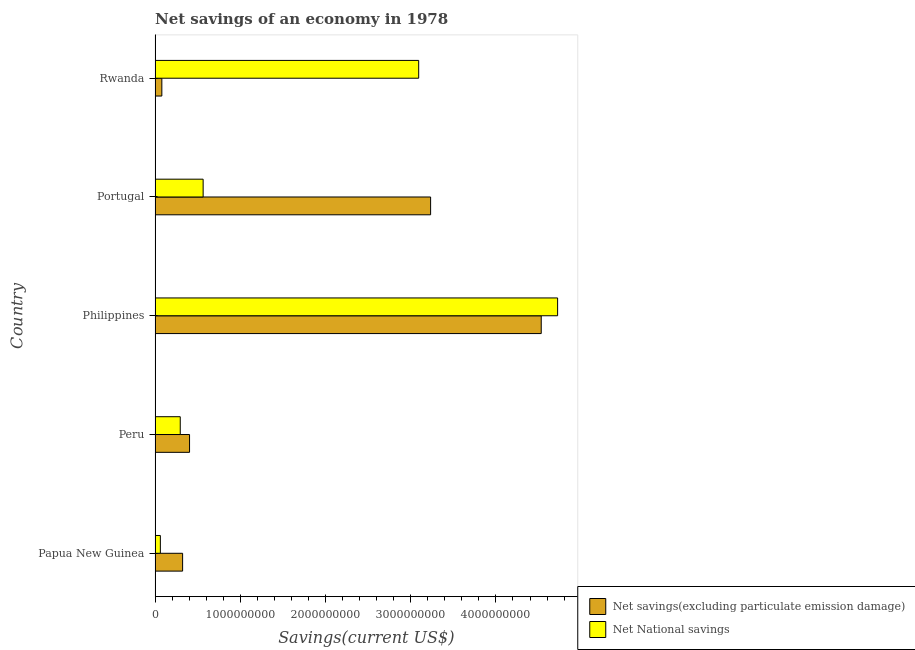How many bars are there on the 3rd tick from the bottom?
Ensure brevity in your answer.  2. In how many cases, is the number of bars for a given country not equal to the number of legend labels?
Keep it short and to the point. 0. What is the net national savings in Rwanda?
Your response must be concise. 3.09e+09. Across all countries, what is the maximum net national savings?
Provide a succinct answer. 4.72e+09. Across all countries, what is the minimum net savings(excluding particulate emission damage)?
Provide a succinct answer. 7.96e+07. In which country was the net national savings minimum?
Keep it short and to the point. Papua New Guinea. What is the total net national savings in the graph?
Provide a short and direct response. 8.74e+09. What is the difference between the net national savings in Papua New Guinea and that in Rwanda?
Keep it short and to the point. -3.03e+09. What is the difference between the net national savings in Papua New Guinea and the net savings(excluding particulate emission damage) in Peru?
Give a very brief answer. -3.43e+08. What is the average net savings(excluding particulate emission damage) per country?
Provide a succinct answer. 1.71e+09. What is the difference between the net savings(excluding particulate emission damage) and net national savings in Rwanda?
Ensure brevity in your answer.  -3.01e+09. In how many countries, is the net national savings greater than 2400000000 US$?
Your answer should be very brief. 2. What is the ratio of the net savings(excluding particulate emission damage) in Peru to that in Philippines?
Give a very brief answer. 0.09. Is the net national savings in Philippines less than that in Portugal?
Keep it short and to the point. No. Is the difference between the net national savings in Portugal and Rwanda greater than the difference between the net savings(excluding particulate emission damage) in Portugal and Rwanda?
Your answer should be very brief. No. What is the difference between the highest and the second highest net national savings?
Offer a terse response. 1.63e+09. What is the difference between the highest and the lowest net savings(excluding particulate emission damage)?
Provide a succinct answer. 4.45e+09. In how many countries, is the net national savings greater than the average net national savings taken over all countries?
Provide a succinct answer. 2. Is the sum of the net national savings in Peru and Rwanda greater than the maximum net savings(excluding particulate emission damage) across all countries?
Your answer should be very brief. No. What does the 1st bar from the top in Peru represents?
Provide a short and direct response. Net National savings. What does the 1st bar from the bottom in Papua New Guinea represents?
Give a very brief answer. Net savings(excluding particulate emission damage). How many bars are there?
Ensure brevity in your answer.  10. Are all the bars in the graph horizontal?
Your answer should be compact. Yes. Are the values on the major ticks of X-axis written in scientific E-notation?
Your answer should be compact. No. Does the graph contain any zero values?
Provide a short and direct response. No. Does the graph contain grids?
Provide a short and direct response. No. Where does the legend appear in the graph?
Your response must be concise. Bottom right. How are the legend labels stacked?
Give a very brief answer. Vertical. What is the title of the graph?
Ensure brevity in your answer.  Net savings of an economy in 1978. What is the label or title of the X-axis?
Your answer should be very brief. Savings(current US$). What is the label or title of the Y-axis?
Offer a very short reply. Country. What is the Savings(current US$) in Net savings(excluding particulate emission damage) in Papua New Guinea?
Offer a terse response. 3.23e+08. What is the Savings(current US$) of Net National savings in Papua New Guinea?
Keep it short and to the point. 6.22e+07. What is the Savings(current US$) in Net savings(excluding particulate emission damage) in Peru?
Offer a terse response. 4.05e+08. What is the Savings(current US$) in Net National savings in Peru?
Your answer should be compact. 2.96e+08. What is the Savings(current US$) in Net savings(excluding particulate emission damage) in Philippines?
Your answer should be compact. 4.53e+09. What is the Savings(current US$) in Net National savings in Philippines?
Your response must be concise. 4.72e+09. What is the Savings(current US$) of Net savings(excluding particulate emission damage) in Portugal?
Your response must be concise. 3.23e+09. What is the Savings(current US$) of Net National savings in Portugal?
Ensure brevity in your answer.  5.64e+08. What is the Savings(current US$) of Net savings(excluding particulate emission damage) in Rwanda?
Make the answer very short. 7.96e+07. What is the Savings(current US$) in Net National savings in Rwanda?
Make the answer very short. 3.09e+09. Across all countries, what is the maximum Savings(current US$) of Net savings(excluding particulate emission damage)?
Your answer should be very brief. 4.53e+09. Across all countries, what is the maximum Savings(current US$) of Net National savings?
Offer a very short reply. 4.72e+09. Across all countries, what is the minimum Savings(current US$) of Net savings(excluding particulate emission damage)?
Provide a short and direct response. 7.96e+07. Across all countries, what is the minimum Savings(current US$) in Net National savings?
Your response must be concise. 6.22e+07. What is the total Savings(current US$) of Net savings(excluding particulate emission damage) in the graph?
Your response must be concise. 8.57e+09. What is the total Savings(current US$) in Net National savings in the graph?
Provide a succinct answer. 8.74e+09. What is the difference between the Savings(current US$) in Net savings(excluding particulate emission damage) in Papua New Guinea and that in Peru?
Offer a terse response. -8.15e+07. What is the difference between the Savings(current US$) in Net National savings in Papua New Guinea and that in Peru?
Make the answer very short. -2.33e+08. What is the difference between the Savings(current US$) in Net savings(excluding particulate emission damage) in Papua New Guinea and that in Philippines?
Make the answer very short. -4.21e+09. What is the difference between the Savings(current US$) in Net National savings in Papua New Guinea and that in Philippines?
Your answer should be compact. -4.66e+09. What is the difference between the Savings(current US$) of Net savings(excluding particulate emission damage) in Papua New Guinea and that in Portugal?
Keep it short and to the point. -2.91e+09. What is the difference between the Savings(current US$) of Net National savings in Papua New Guinea and that in Portugal?
Give a very brief answer. -5.02e+08. What is the difference between the Savings(current US$) in Net savings(excluding particulate emission damage) in Papua New Guinea and that in Rwanda?
Your answer should be very brief. 2.44e+08. What is the difference between the Savings(current US$) of Net National savings in Papua New Guinea and that in Rwanda?
Ensure brevity in your answer.  -3.03e+09. What is the difference between the Savings(current US$) in Net savings(excluding particulate emission damage) in Peru and that in Philippines?
Provide a short and direct response. -4.13e+09. What is the difference between the Savings(current US$) in Net National savings in Peru and that in Philippines?
Offer a very short reply. -4.43e+09. What is the difference between the Savings(current US$) in Net savings(excluding particulate emission damage) in Peru and that in Portugal?
Provide a succinct answer. -2.83e+09. What is the difference between the Savings(current US$) of Net National savings in Peru and that in Portugal?
Provide a succinct answer. -2.69e+08. What is the difference between the Savings(current US$) in Net savings(excluding particulate emission damage) in Peru and that in Rwanda?
Your answer should be compact. 3.25e+08. What is the difference between the Savings(current US$) in Net National savings in Peru and that in Rwanda?
Ensure brevity in your answer.  -2.80e+09. What is the difference between the Savings(current US$) in Net savings(excluding particulate emission damage) in Philippines and that in Portugal?
Provide a short and direct response. 1.30e+09. What is the difference between the Savings(current US$) of Net National savings in Philippines and that in Portugal?
Make the answer very short. 4.16e+09. What is the difference between the Savings(current US$) in Net savings(excluding particulate emission damage) in Philippines and that in Rwanda?
Your answer should be very brief. 4.45e+09. What is the difference between the Savings(current US$) of Net National savings in Philippines and that in Rwanda?
Make the answer very short. 1.63e+09. What is the difference between the Savings(current US$) of Net savings(excluding particulate emission damage) in Portugal and that in Rwanda?
Provide a short and direct response. 3.15e+09. What is the difference between the Savings(current US$) of Net National savings in Portugal and that in Rwanda?
Give a very brief answer. -2.53e+09. What is the difference between the Savings(current US$) in Net savings(excluding particulate emission damage) in Papua New Guinea and the Savings(current US$) in Net National savings in Peru?
Give a very brief answer. 2.77e+07. What is the difference between the Savings(current US$) in Net savings(excluding particulate emission damage) in Papua New Guinea and the Savings(current US$) in Net National savings in Philippines?
Provide a short and direct response. -4.40e+09. What is the difference between the Savings(current US$) in Net savings(excluding particulate emission damage) in Papua New Guinea and the Savings(current US$) in Net National savings in Portugal?
Keep it short and to the point. -2.41e+08. What is the difference between the Savings(current US$) in Net savings(excluding particulate emission damage) in Papua New Guinea and the Savings(current US$) in Net National savings in Rwanda?
Offer a very short reply. -2.77e+09. What is the difference between the Savings(current US$) of Net savings(excluding particulate emission damage) in Peru and the Savings(current US$) of Net National savings in Philippines?
Provide a succinct answer. -4.32e+09. What is the difference between the Savings(current US$) of Net savings(excluding particulate emission damage) in Peru and the Savings(current US$) of Net National savings in Portugal?
Your answer should be very brief. -1.60e+08. What is the difference between the Savings(current US$) in Net savings(excluding particulate emission damage) in Peru and the Savings(current US$) in Net National savings in Rwanda?
Your answer should be compact. -2.69e+09. What is the difference between the Savings(current US$) of Net savings(excluding particulate emission damage) in Philippines and the Savings(current US$) of Net National savings in Portugal?
Provide a succinct answer. 3.97e+09. What is the difference between the Savings(current US$) of Net savings(excluding particulate emission damage) in Philippines and the Savings(current US$) of Net National savings in Rwanda?
Make the answer very short. 1.44e+09. What is the difference between the Savings(current US$) in Net savings(excluding particulate emission damage) in Portugal and the Savings(current US$) in Net National savings in Rwanda?
Make the answer very short. 1.40e+08. What is the average Savings(current US$) of Net savings(excluding particulate emission damage) per country?
Make the answer very short. 1.71e+09. What is the average Savings(current US$) in Net National savings per country?
Provide a short and direct response. 1.75e+09. What is the difference between the Savings(current US$) in Net savings(excluding particulate emission damage) and Savings(current US$) in Net National savings in Papua New Guinea?
Make the answer very short. 2.61e+08. What is the difference between the Savings(current US$) in Net savings(excluding particulate emission damage) and Savings(current US$) in Net National savings in Peru?
Ensure brevity in your answer.  1.09e+08. What is the difference between the Savings(current US$) of Net savings(excluding particulate emission damage) and Savings(current US$) of Net National savings in Philippines?
Ensure brevity in your answer.  -1.92e+08. What is the difference between the Savings(current US$) in Net savings(excluding particulate emission damage) and Savings(current US$) in Net National savings in Portugal?
Provide a short and direct response. 2.67e+09. What is the difference between the Savings(current US$) in Net savings(excluding particulate emission damage) and Savings(current US$) in Net National savings in Rwanda?
Keep it short and to the point. -3.01e+09. What is the ratio of the Savings(current US$) in Net savings(excluding particulate emission damage) in Papua New Guinea to that in Peru?
Offer a terse response. 0.8. What is the ratio of the Savings(current US$) in Net National savings in Papua New Guinea to that in Peru?
Your response must be concise. 0.21. What is the ratio of the Savings(current US$) of Net savings(excluding particulate emission damage) in Papua New Guinea to that in Philippines?
Your response must be concise. 0.07. What is the ratio of the Savings(current US$) of Net National savings in Papua New Guinea to that in Philippines?
Your answer should be very brief. 0.01. What is the ratio of the Savings(current US$) in Net savings(excluding particulate emission damage) in Papua New Guinea to that in Portugal?
Your answer should be very brief. 0.1. What is the ratio of the Savings(current US$) of Net National savings in Papua New Guinea to that in Portugal?
Give a very brief answer. 0.11. What is the ratio of the Savings(current US$) of Net savings(excluding particulate emission damage) in Papua New Guinea to that in Rwanda?
Provide a succinct answer. 4.06. What is the ratio of the Savings(current US$) in Net National savings in Papua New Guinea to that in Rwanda?
Offer a very short reply. 0.02. What is the ratio of the Savings(current US$) of Net savings(excluding particulate emission damage) in Peru to that in Philippines?
Provide a short and direct response. 0.09. What is the ratio of the Savings(current US$) in Net National savings in Peru to that in Philippines?
Your response must be concise. 0.06. What is the ratio of the Savings(current US$) of Net savings(excluding particulate emission damage) in Peru to that in Portugal?
Provide a short and direct response. 0.13. What is the ratio of the Savings(current US$) in Net National savings in Peru to that in Portugal?
Your answer should be very brief. 0.52. What is the ratio of the Savings(current US$) in Net savings(excluding particulate emission damage) in Peru to that in Rwanda?
Your answer should be very brief. 5.08. What is the ratio of the Savings(current US$) of Net National savings in Peru to that in Rwanda?
Your answer should be very brief. 0.1. What is the ratio of the Savings(current US$) of Net savings(excluding particulate emission damage) in Philippines to that in Portugal?
Ensure brevity in your answer.  1.4. What is the ratio of the Savings(current US$) in Net National savings in Philippines to that in Portugal?
Provide a short and direct response. 8.37. What is the ratio of the Savings(current US$) of Net savings(excluding particulate emission damage) in Philippines to that in Rwanda?
Offer a terse response. 56.9. What is the ratio of the Savings(current US$) in Net National savings in Philippines to that in Rwanda?
Your response must be concise. 1.53. What is the ratio of the Savings(current US$) in Net savings(excluding particulate emission damage) in Portugal to that in Rwanda?
Your answer should be compact. 40.6. What is the ratio of the Savings(current US$) of Net National savings in Portugal to that in Rwanda?
Your answer should be very brief. 0.18. What is the difference between the highest and the second highest Savings(current US$) in Net savings(excluding particulate emission damage)?
Your answer should be compact. 1.30e+09. What is the difference between the highest and the second highest Savings(current US$) in Net National savings?
Provide a short and direct response. 1.63e+09. What is the difference between the highest and the lowest Savings(current US$) of Net savings(excluding particulate emission damage)?
Your answer should be very brief. 4.45e+09. What is the difference between the highest and the lowest Savings(current US$) in Net National savings?
Your answer should be very brief. 4.66e+09. 